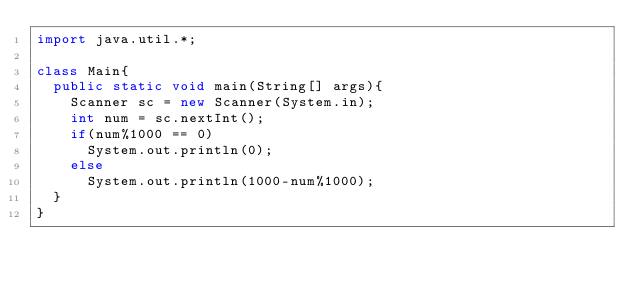<code> <loc_0><loc_0><loc_500><loc_500><_Java_>import java.util.*;
 
class Main{
  public static void main(String[] args){
    Scanner sc = new Scanner(System.in);
    int num = sc.nextInt();
    if(num%1000 == 0)
      System.out.println(0);
    else
      System.out.println(1000-num%1000);
  }
}</code> 